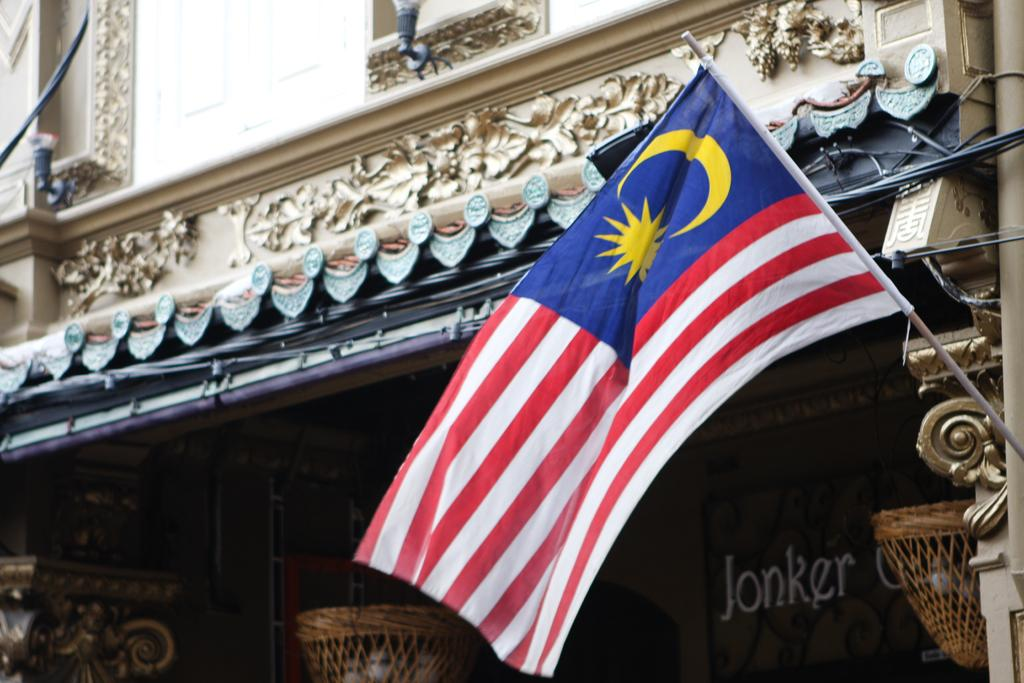What can be seen flying or waving in the image? There is a flag in the image. What is supporting the flag in the image? There is a rod in the image that supports the flag. What connects the flag to the rod? Cables are present in the image, connecting the flag to the rod. What is visible in the background of the image? There is a wall in the image. What type of containers are present in the image? There are baskets in the image. What else can be seen in the image besides the flag, rod, cables, wall, and baskets? There are objects in the image. What is written or displayed on a board in the image? Something is written on a board in the image. What type of winter clothing is visible on the train in the image? There is no train present in the image, and therefore no winter clothing can be observed. 